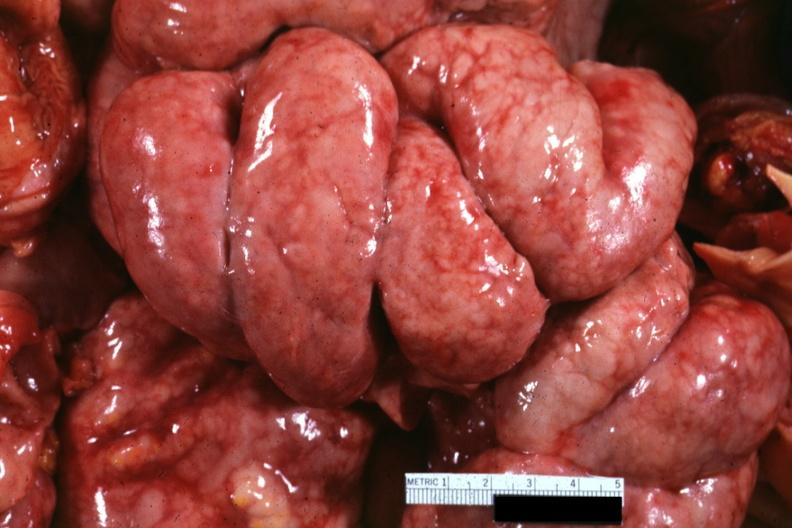s abdomen present?
Answer the question using a single word or phrase. Yes 